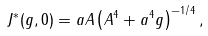Convert formula to latex. <formula><loc_0><loc_0><loc_500><loc_500>J ^ { * } ( g , 0 ) = a A \left ( A ^ { 4 } + a ^ { 4 } g \right ) ^ { - 1 / 4 } ,</formula> 